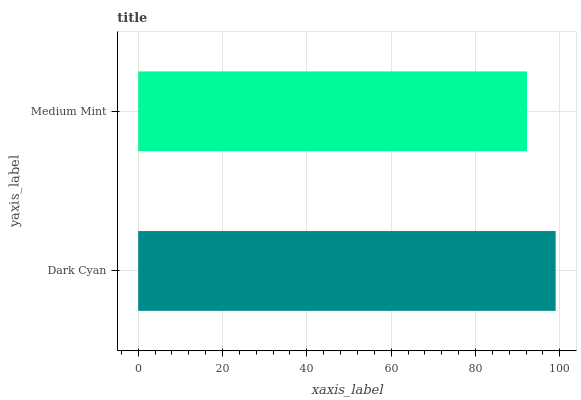Is Medium Mint the minimum?
Answer yes or no. Yes. Is Dark Cyan the maximum?
Answer yes or no. Yes. Is Medium Mint the maximum?
Answer yes or no. No. Is Dark Cyan greater than Medium Mint?
Answer yes or no. Yes. Is Medium Mint less than Dark Cyan?
Answer yes or no. Yes. Is Medium Mint greater than Dark Cyan?
Answer yes or no. No. Is Dark Cyan less than Medium Mint?
Answer yes or no. No. Is Dark Cyan the high median?
Answer yes or no. Yes. Is Medium Mint the low median?
Answer yes or no. Yes. Is Medium Mint the high median?
Answer yes or no. No. Is Dark Cyan the low median?
Answer yes or no. No. 